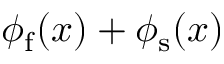Convert formula to latex. <formula><loc_0><loc_0><loc_500><loc_500>\phi _ { f } ( x ) + \phi _ { s } ( x )</formula> 